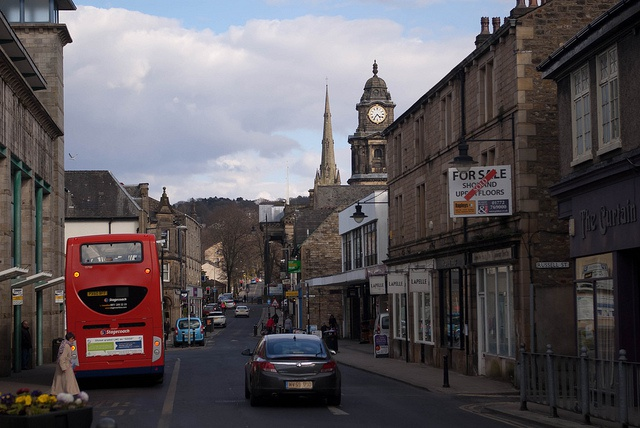Describe the objects in this image and their specific colors. I can see bus in black, maroon, brown, and gray tones, car in black, gray, darkblue, and navy tones, people in black and gray tones, car in black, blue, gray, and darkblue tones, and clock in black, lightgray, tan, gray, and darkgray tones in this image. 